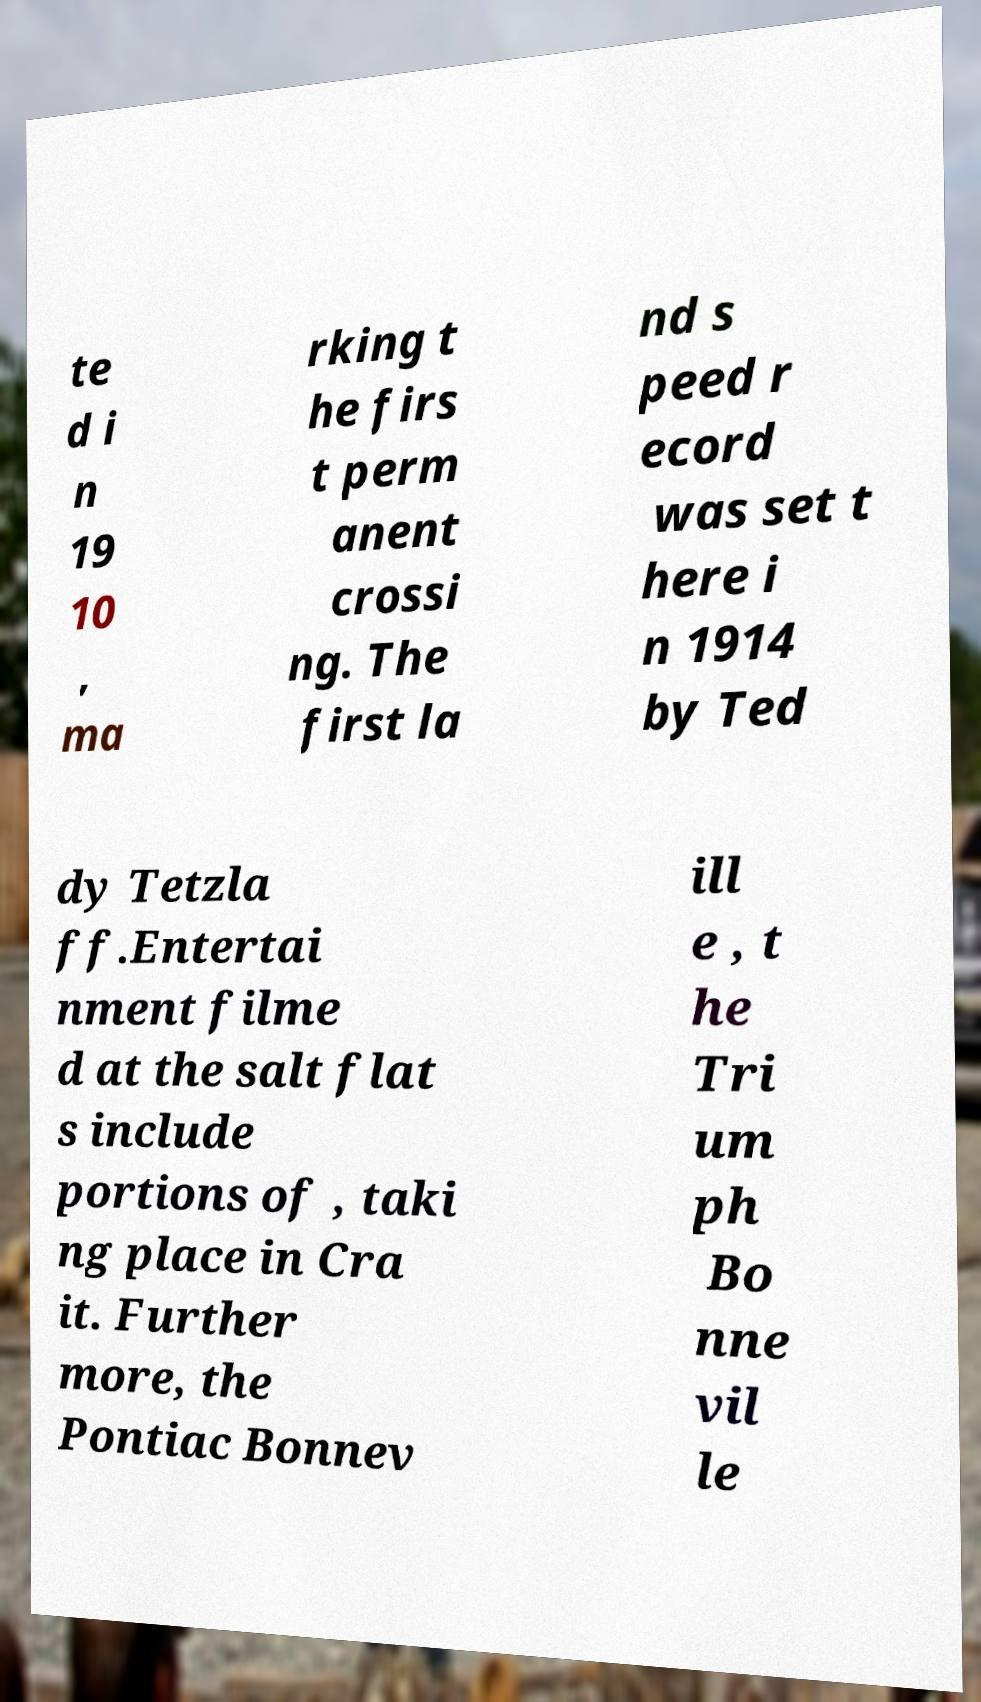There's text embedded in this image that I need extracted. Can you transcribe it verbatim? te d i n 19 10 , ma rking t he firs t perm anent crossi ng. The first la nd s peed r ecord was set t here i n 1914 by Ted dy Tetzla ff.Entertai nment filme d at the salt flat s include portions of , taki ng place in Cra it. Further more, the Pontiac Bonnev ill e , t he Tri um ph Bo nne vil le 